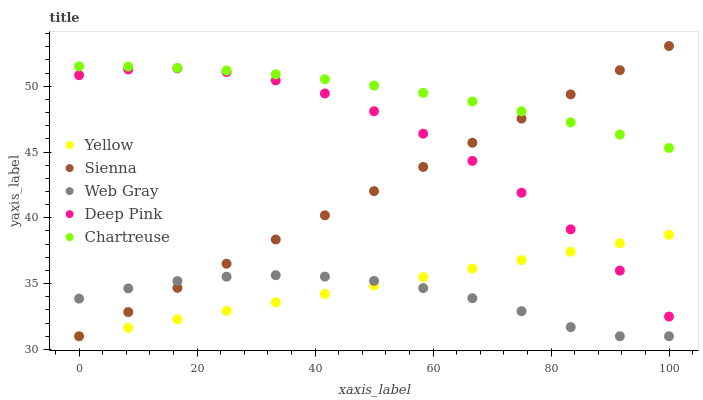Does Web Gray have the minimum area under the curve?
Answer yes or no. Yes. Does Chartreuse have the maximum area under the curve?
Answer yes or no. Yes. Does Chartreuse have the minimum area under the curve?
Answer yes or no. No. Does Web Gray have the maximum area under the curve?
Answer yes or no. No. Is Yellow the smoothest?
Answer yes or no. Yes. Is Deep Pink the roughest?
Answer yes or no. Yes. Is Chartreuse the smoothest?
Answer yes or no. No. Is Chartreuse the roughest?
Answer yes or no. No. Does Sienna have the lowest value?
Answer yes or no. Yes. Does Chartreuse have the lowest value?
Answer yes or no. No. Does Sienna have the highest value?
Answer yes or no. Yes. Does Chartreuse have the highest value?
Answer yes or no. No. Is Web Gray less than Chartreuse?
Answer yes or no. Yes. Is Deep Pink greater than Web Gray?
Answer yes or no. Yes. Does Sienna intersect Deep Pink?
Answer yes or no. Yes. Is Sienna less than Deep Pink?
Answer yes or no. No. Is Sienna greater than Deep Pink?
Answer yes or no. No. Does Web Gray intersect Chartreuse?
Answer yes or no. No. 